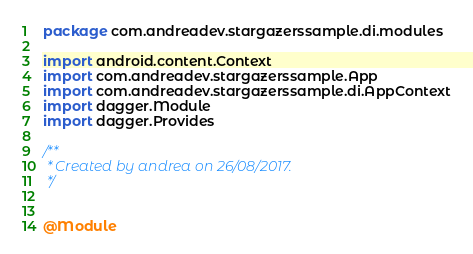<code> <loc_0><loc_0><loc_500><loc_500><_Kotlin_>package com.andreadev.stargazerssample.di.modules

import android.content.Context
import com.andreadev.stargazerssample.App
import com.andreadev.stargazerssample.di.AppContext
import dagger.Module
import dagger.Provides

/**
 * Created by andrea on 26/08/2017.
 */


@Module</code> 